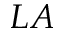Convert formula to latex. <formula><loc_0><loc_0><loc_500><loc_500>L A</formula> 